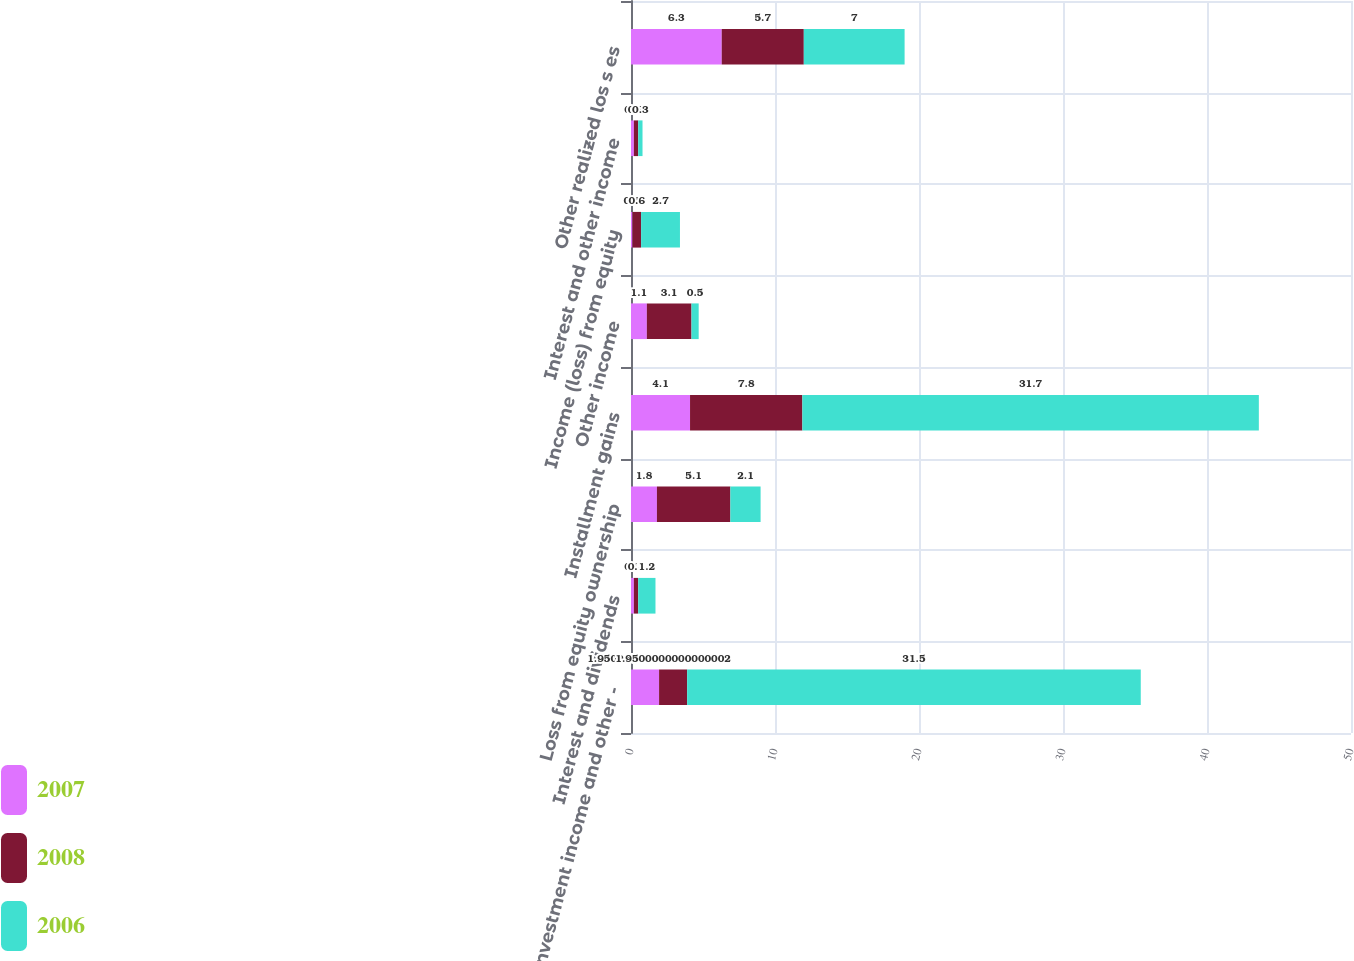Convert chart. <chart><loc_0><loc_0><loc_500><loc_500><stacked_bar_chart><ecel><fcel>Investment income and other -<fcel>Interest and dividends<fcel>Loss from equity ownership<fcel>Installment gains<fcel>Other income<fcel>Income (loss) from equity<fcel>Interest and other income<fcel>Other realized los s es<nl><fcel>2007<fcel>1.95<fcel>0.2<fcel>1.8<fcel>4.1<fcel>1.1<fcel>0.1<fcel>0.2<fcel>6.3<nl><fcel>2008<fcel>1.95<fcel>0.3<fcel>5.1<fcel>7.8<fcel>3.1<fcel>0.6<fcel>0.3<fcel>5.7<nl><fcel>2006<fcel>31.5<fcel>1.2<fcel>2.1<fcel>31.7<fcel>0.5<fcel>2.7<fcel>0.3<fcel>7<nl></chart> 